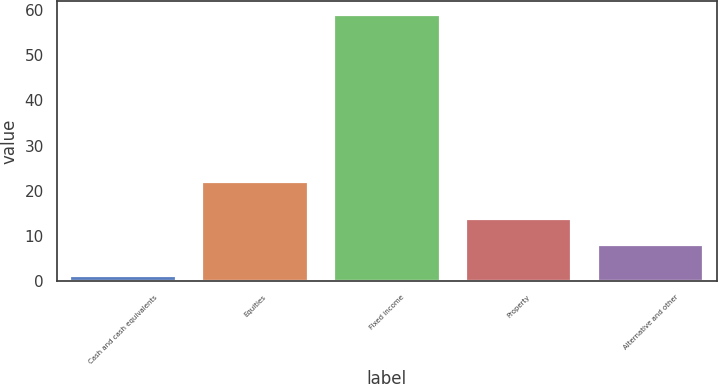Convert chart. <chart><loc_0><loc_0><loc_500><loc_500><bar_chart><fcel>Cash and cash equivalents<fcel>Equities<fcel>Fixed income<fcel>Property<fcel>Alternative and other<nl><fcel>1<fcel>22<fcel>59<fcel>13.8<fcel>8<nl></chart> 